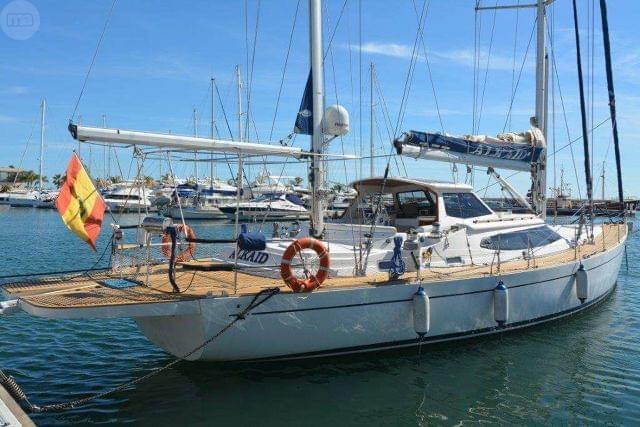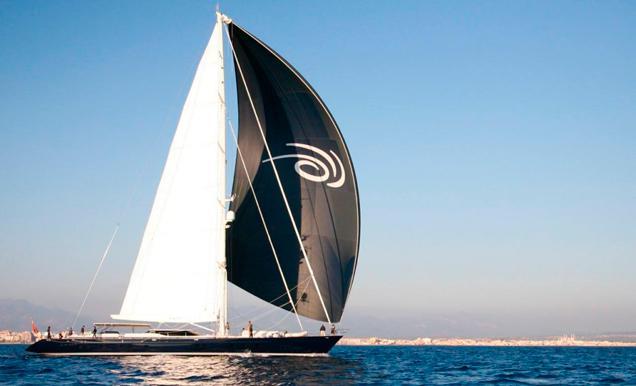The first image is the image on the left, the second image is the image on the right. For the images shown, is this caption "There is one sailboat without the sails unfurled." true? Answer yes or no. Yes. 